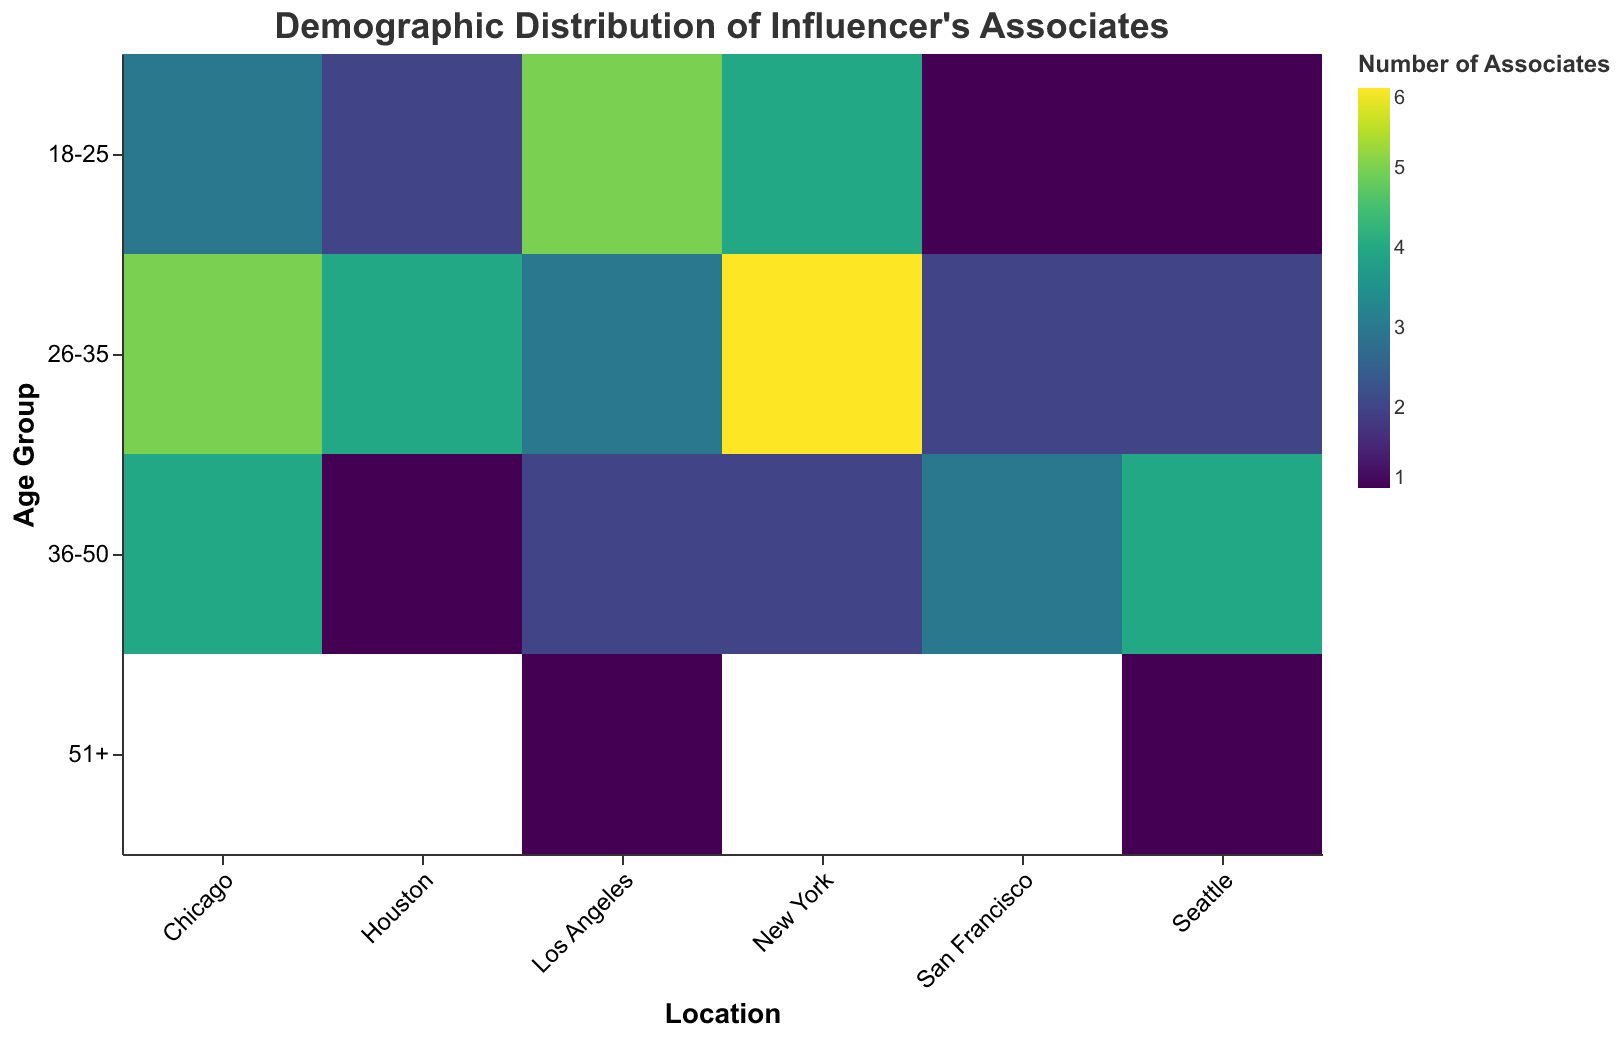What is the title of the heatmap? The title is displayed prominently at the top of the heatmap and reads "Demographic Distribution of Influencer's Associates".
Answer: Demographic Distribution of Influencer's Associates Which city has the highest number of associates in the 26-35 age group? Look at the color gradients in the row corresponding to the 26-35 age group. The cell with the darkest color, which indicates the highest value, is New York.
Answer: New York What is the number of male associates aged 18-25 in Los Angeles? Hover over the cell at the intersection of Los Angeles and the 18-25 age group row, and the tooltip will display "Gender: Male" and "Number of Associates: 5".
Answer: 5 How many age groups are represented in the heatmap? Count the unique categories along the y-axis labeled "Age Group". The categories are 18-25, 26-35, 36-50, and 51+.
Answer: 4 Which location has the fewest associates across all age groups? Sum the number of associates for each location across all age groups and compare. Seattle has the fewest with a total of 8 associates (1+2+4+1).
Answer: Seattle Between Chicago and Houston, which city has more female associates in the 26-35 age group? Look at the color intensity for the cells at the intersection of these locations and the 26-35 age group. Hover to get the specific numbers: Chicago has 5 female associates, while Houston has none.
Answer: Chicago How many female associates aged 36-50 are there in Seattle? Hover over the cell at the intersection of Seattle and the 36-50 age group row, and the tooltip will display "Gender: Female" and "Number of Associates: 4".
Answer: 4 Which age group has the highest number of associates in New York? Look at the New York column from top to bottom and identify the age group with the darkest color. The 26-35 age group has the highest number of associates with 6.
Answer: 26-35 Compare the number of male associates aged 18-25 between Los Angeles and Chicago. Which city has more? Check the values in the cells for Los Angeles and Chicago in the 18-25 age group row. Los Angeles has 5 male associates, while Chicago has 3. Thus, Los Angeles has more.
Answer: Los Angeles In which age group do Houston and San Francisco have the same number of associates? Compare the values across Houston and San Francisco for each age group. Both cities have 3 associates in the 36-50 age group (Houston: 1 Female, 2 Male; San Francisco: 3 Male).
Answer: 36-50 